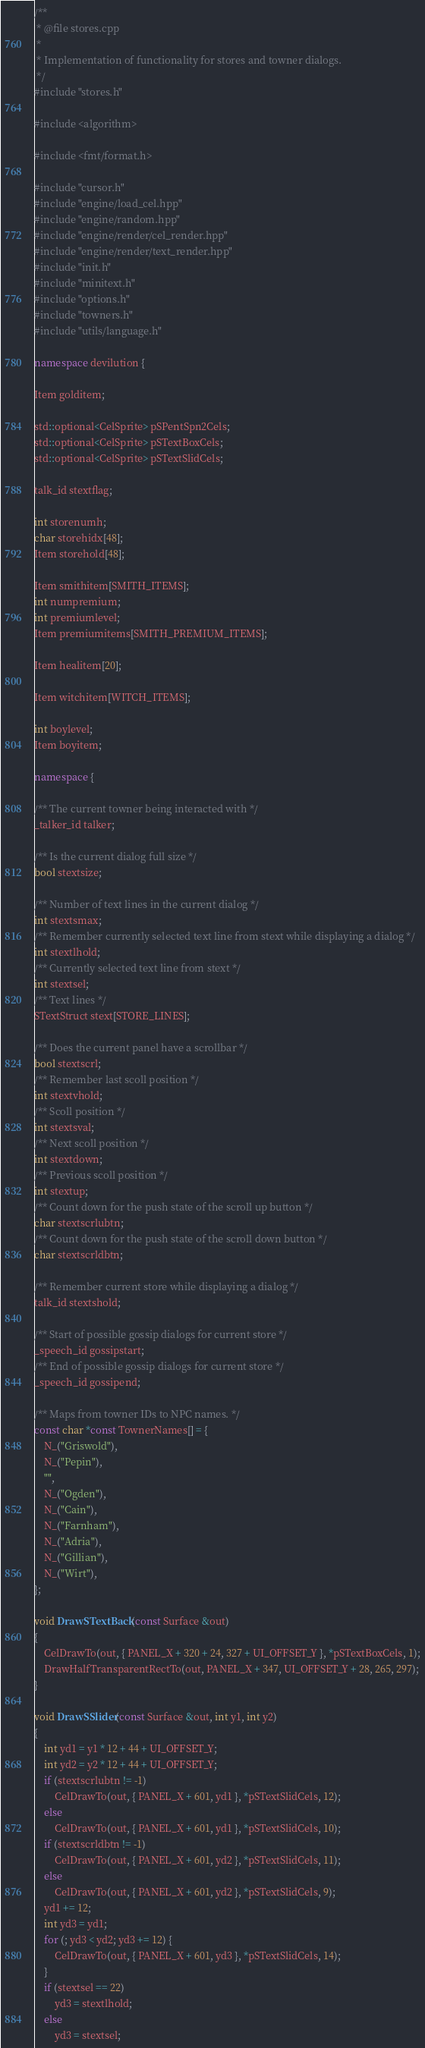<code> <loc_0><loc_0><loc_500><loc_500><_C++_>/**
 * @file stores.cpp
 *
 * Implementation of functionality for stores and towner dialogs.
 */
#include "stores.h"

#include <algorithm>

#include <fmt/format.h>

#include "cursor.h"
#include "engine/load_cel.hpp"
#include "engine/random.hpp"
#include "engine/render/cel_render.hpp"
#include "engine/render/text_render.hpp"
#include "init.h"
#include "minitext.h"
#include "options.h"
#include "towners.h"
#include "utils/language.h"

namespace devilution {

Item golditem;

std::optional<CelSprite> pSPentSpn2Cels;
std::optional<CelSprite> pSTextBoxCels;
std::optional<CelSprite> pSTextSlidCels;

talk_id stextflag;

int storenumh;
char storehidx[48];
Item storehold[48];

Item smithitem[SMITH_ITEMS];
int numpremium;
int premiumlevel;
Item premiumitems[SMITH_PREMIUM_ITEMS];

Item healitem[20];

Item witchitem[WITCH_ITEMS];

int boylevel;
Item boyitem;

namespace {

/** The current towner being interacted with */
_talker_id talker;

/** Is the current dialog full size */
bool stextsize;

/** Number of text lines in the current dialog */
int stextsmax;
/** Remember currently selected text line from stext while displaying a dialog */
int stextlhold;
/** Currently selected text line from stext */
int stextsel;
/** Text lines */
STextStruct stext[STORE_LINES];

/** Does the current panel have a scrollbar */
bool stextscrl;
/** Remember last scoll position */
int stextvhold;
/** Scoll position */
int stextsval;
/** Next scoll position */
int stextdown;
/** Previous scoll position */
int stextup;
/** Count down for the push state of the scroll up button */
char stextscrlubtn;
/** Count down for the push state of the scroll down button */
char stextscrldbtn;

/** Remember current store while displaying a dialog */
talk_id stextshold;

/** Start of possible gossip dialogs for current store */
_speech_id gossipstart;
/** End of possible gossip dialogs for current store */
_speech_id gossipend;

/** Maps from towner IDs to NPC names. */
const char *const TownerNames[] = {
	N_("Griswold"),
	N_("Pepin"),
	"",
	N_("Ogden"),
	N_("Cain"),
	N_("Farnham"),
	N_("Adria"),
	N_("Gillian"),
	N_("Wirt"),
};

void DrawSTextBack(const Surface &out)
{
	CelDrawTo(out, { PANEL_X + 320 + 24, 327 + UI_OFFSET_Y }, *pSTextBoxCels, 1);
	DrawHalfTransparentRectTo(out, PANEL_X + 347, UI_OFFSET_Y + 28, 265, 297);
}

void DrawSSlider(const Surface &out, int y1, int y2)
{
	int yd1 = y1 * 12 + 44 + UI_OFFSET_Y;
	int yd2 = y2 * 12 + 44 + UI_OFFSET_Y;
	if (stextscrlubtn != -1)
		CelDrawTo(out, { PANEL_X + 601, yd1 }, *pSTextSlidCels, 12);
	else
		CelDrawTo(out, { PANEL_X + 601, yd1 }, *pSTextSlidCels, 10);
	if (stextscrldbtn != -1)
		CelDrawTo(out, { PANEL_X + 601, yd2 }, *pSTextSlidCels, 11);
	else
		CelDrawTo(out, { PANEL_X + 601, yd2 }, *pSTextSlidCels, 9);
	yd1 += 12;
	int yd3 = yd1;
	for (; yd3 < yd2; yd3 += 12) {
		CelDrawTo(out, { PANEL_X + 601, yd3 }, *pSTextSlidCels, 14);
	}
	if (stextsel == 22)
		yd3 = stextlhold;
	else
		yd3 = stextsel;</code> 